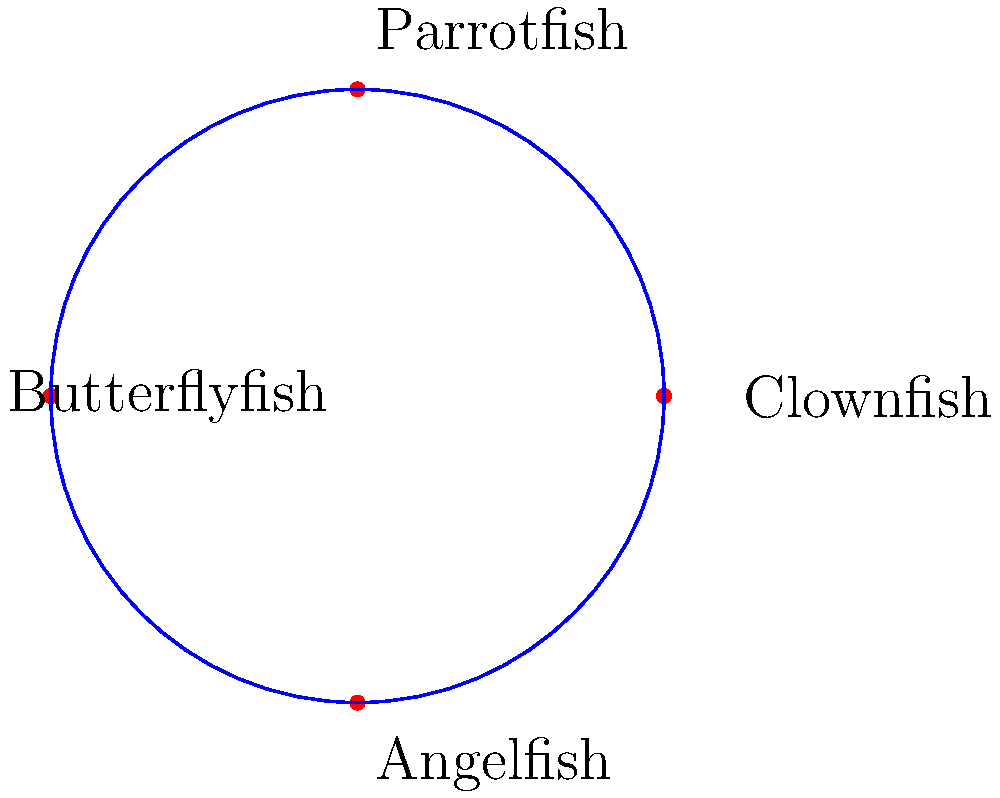In a coral reef ecosystem near Trat, four common fish species are observed: Clownfish, Parrotfish, Butterflyfish, and Angelfish. How many unique ways can these species be arranged in a circular formation for a conservation study, considering rotations of the same arrangement as identical? To solve this problem, we need to use the concept of circular permutations:

1. First, recall that the number of permutations for n distinct objects is n!.

2. However, in a circular arrangement, rotations of the same arrangement are considered identical. This means we need to divide the total number of permutations by the number of rotations possible.

3. For n objects in a circle, there are n possible rotations that produce the same arrangement.

4. Therefore, the formula for circular permutations is: $$(n-1)!$$

5. In this case, we have 4 fish species, so n = 4.

6. Applying the formula: $$(4-1)! = 3! = 3 \times 2 \times 1 = 6$$

Thus, there are 6 unique circular arrangements of the four fish species.

This result is particularly relevant for environmental activists in Trat, as it demonstrates the diversity of possible interactions and formations in coral reef ecosystems, highlighting the importance of preserving these complex marine environments.
Answer: 6 